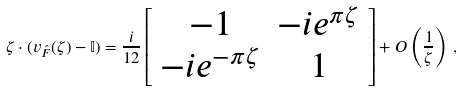Convert formula to latex. <formula><loc_0><loc_0><loc_500><loc_500>\zeta \cdot ( { v } _ { \hat { F } } ( \zeta ) - { \mathbb { I } } ) = \frac { i } { 1 2 } \left [ \begin{array} { c c } - 1 & - i e ^ { \pi \zeta } \\ - i e ^ { - \pi \zeta } & 1 \end{array} \right ] + O \left ( \frac { 1 } { \zeta } \right ) \, ,</formula> 